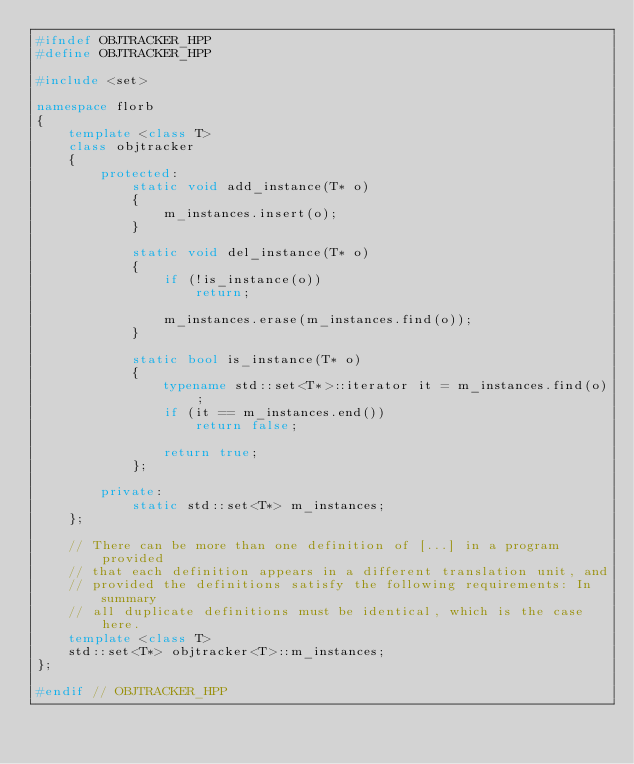Convert code to text. <code><loc_0><loc_0><loc_500><loc_500><_C++_>#ifndef OBJTRACKER_HPP
#define OBJTRACKER_HPP

#include <set>

namespace florb
{
    template <class T>
    class objtracker
    {
        protected:
            static void add_instance(T* o)
            {
                m_instances.insert(o);
            }

            static void del_instance(T* o)
            {
                if (!is_instance(o))
                    return;

                m_instances.erase(m_instances.find(o));
            }

            static bool is_instance(T* o)
            {
                typename std::set<T*>::iterator it = m_instances.find(o);
                if (it == m_instances.end())
                    return false;

                return true;       
            };

        private:
            static std::set<T*> m_instances;
    };

    // There can be more than one definition of [...] in a program provided
    // that each definition appears in a different translation unit, and
    // provided the definitions satisfy the following requirements: In summary
    // all duplicate definitions must be identical, which is the case here.
    template <class T> 
    std::set<T*> objtracker<T>::m_instances;
};

#endif // OBJTRACKER_HPP

</code> 